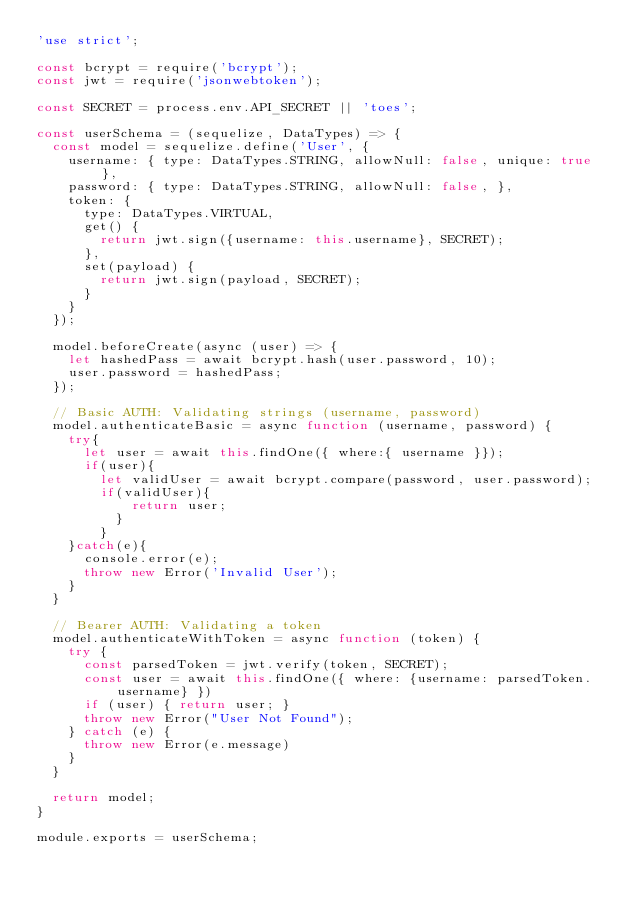Convert code to text. <code><loc_0><loc_0><loc_500><loc_500><_JavaScript_>'use strict';

const bcrypt = require('bcrypt');
const jwt = require('jsonwebtoken');

const SECRET = process.env.API_SECRET || 'toes';

const userSchema = (sequelize, DataTypes) => {
  const model = sequelize.define('User', {
    username: { type: DataTypes.STRING, allowNull: false, unique: true },
    password: { type: DataTypes.STRING, allowNull: false, },
    token: {
      type: DataTypes.VIRTUAL,
      get() {
        return jwt.sign({username: this.username}, SECRET);
      },
      set(payload) {
        return jwt.sign(payload, SECRET);
      }
    }
  });

  model.beforeCreate(async (user) => {
    let hashedPass = await bcrypt.hash(user.password, 10);
    user.password = hashedPass;
  });

  // Basic AUTH: Validating strings (username, password) 
  model.authenticateBasic = async function (username, password) {
    try{
      let user = await this.findOne({ where:{ username }});
      if(user){
        let validUser = await bcrypt.compare(password, user.password);
        if(validUser){
            return user;
          }
        }
    }catch(e){
      console.error(e);
      throw new Error('Invalid User');
    }
  }

  // Bearer AUTH: Validating a token
  model.authenticateWithToken = async function (token) {
    try {
      const parsedToken = jwt.verify(token, SECRET);
      const user = await this.findOne({ where: {username: parsedToken.username} })
      if (user) { return user; }
      throw new Error("User Not Found");
    } catch (e) {
      throw new Error(e.message)
    }
  }

  return model;
}

module.exports = userSchema;
</code> 